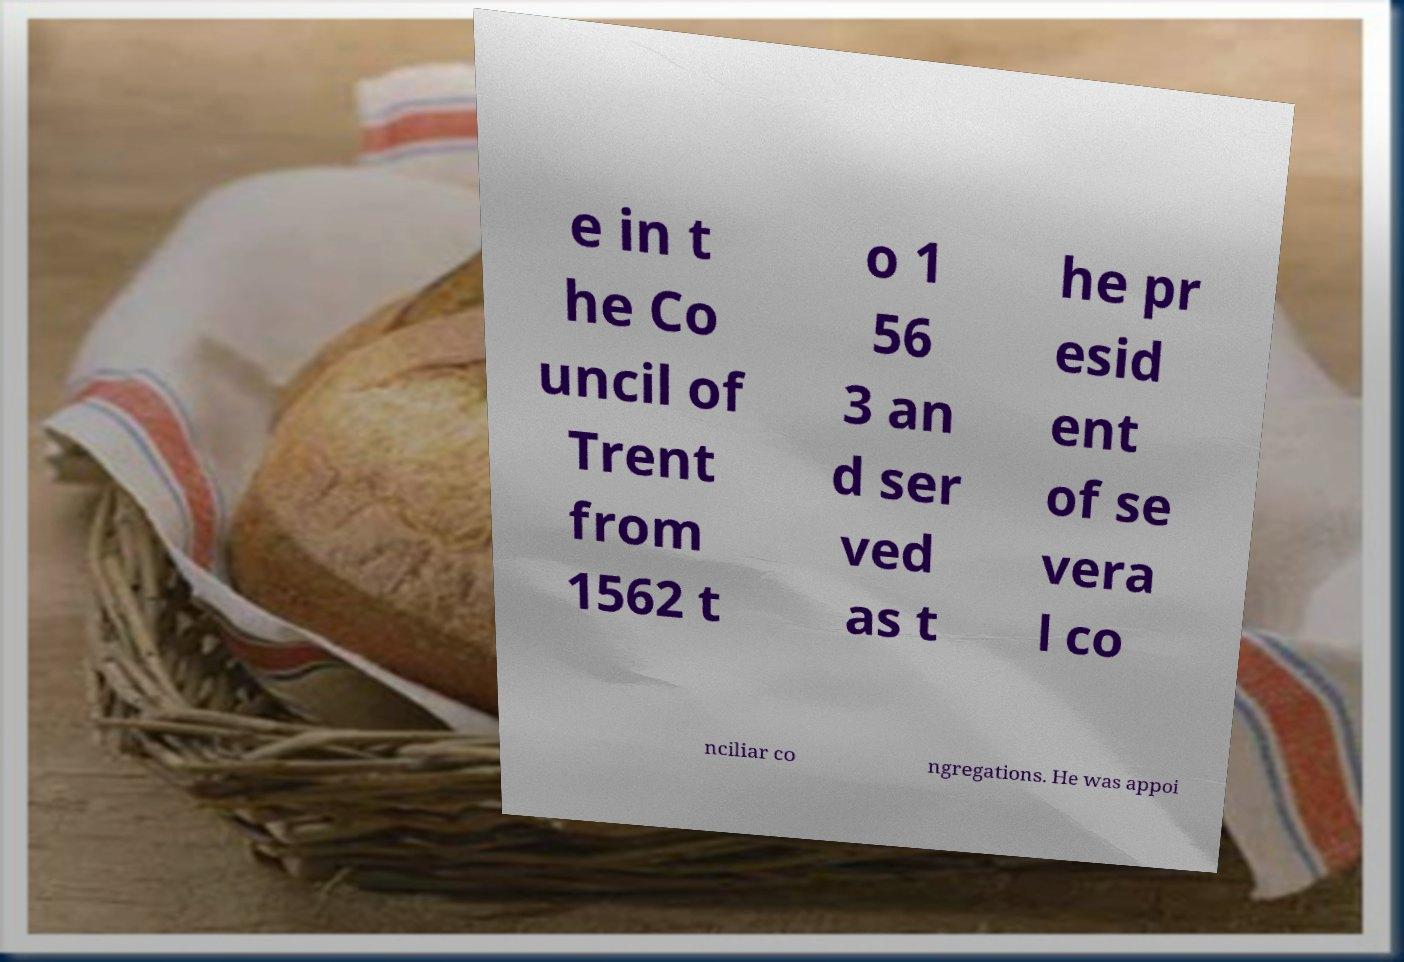What messages or text are displayed in this image? I need them in a readable, typed format. e in t he Co uncil of Trent from 1562 t o 1 56 3 an d ser ved as t he pr esid ent of se vera l co nciliar co ngregations. He was appoi 